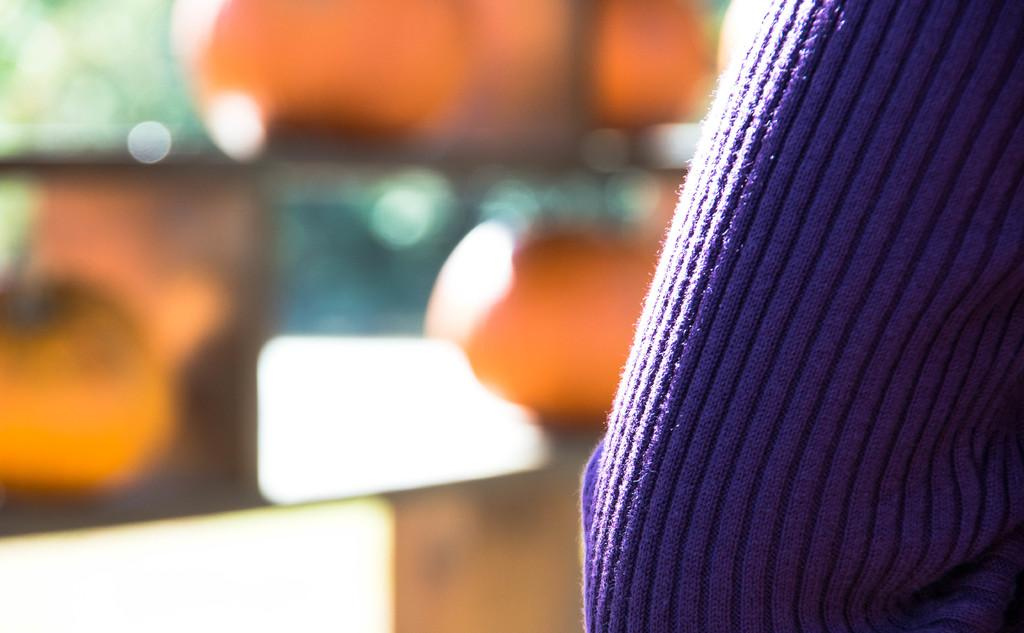What is located on the right side of the image? There is a cloth on the right side of the image. Can you describe the background of the image? The background of the image is blurry. How many cherries can be seen on the tiger's stomach in the image? There is no tiger or cherries present in the image, so it is not possible to answer that question. 